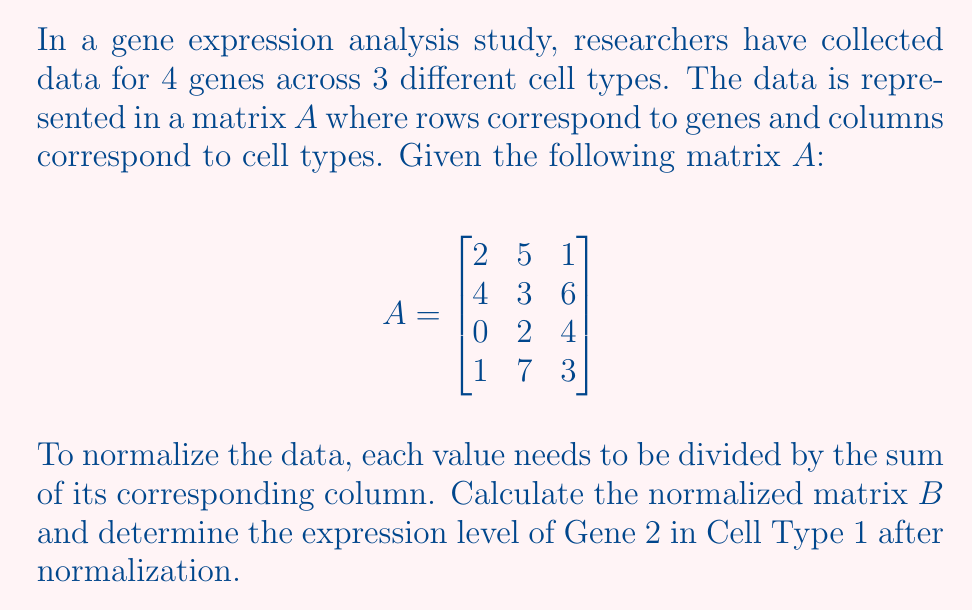Give your solution to this math problem. To solve this problem, we'll follow these steps:

1) First, we need to calculate the sum of each column in matrix $A$:
   Column 1: $2 + 4 + 0 + 1 = 7$
   Column 2: $5 + 3 + 2 + 7 = 17$
   Column 3: $1 + 6 + 4 + 3 = 14$

2) Now, we can create the normalized matrix $B$ by dividing each element by its column sum:

   $$B = \begin{bmatrix}
   2/7 & 5/17 & 1/14 \\
   4/7 & 3/17 & 6/14 \\
   0/7 & 2/17 & 4/14 \\
   1/7 & 7/17 & 3/14
   \end{bmatrix}$$

3) Simplifying the fractions:

   $$B \approx \begin{bmatrix}
   0.2857 & 0.2941 & 0.0714 \\
   0.5714 & 0.1765 & 0.4286 \\
   0 & 0.1176 & 0.2857 \\
   0.1429 & 0.4118 & 0.2143
   \end{bmatrix}$$

4) The question asks for the expression level of Gene 2 in Cell Type 1 after normalization. In the normalized matrix $B$, this corresponds to the element in the second row, first column.

5) From our calculations, we can see that this value is $4/7 \approx 0.5714$.
Answer: $\frac{4}{7}$ or approximately 0.5714 